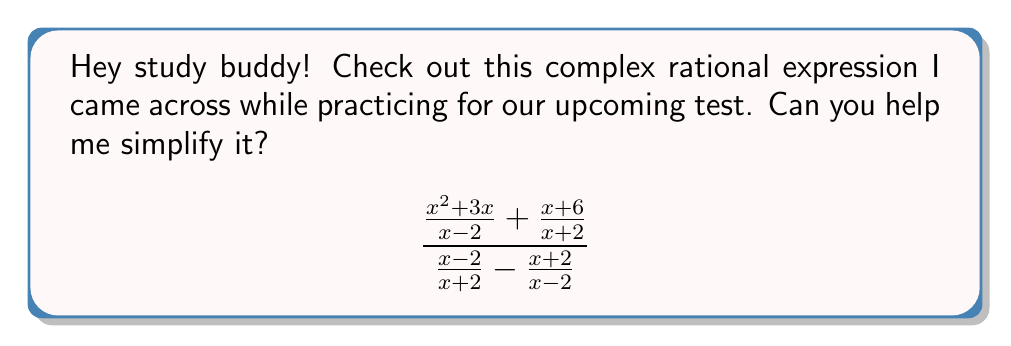Give your solution to this math problem. Sure! Let's break this down step-by-step:

1) First, let's find a common denominator for the numerator and denominator separately.

   For the numerator: LCD = $(x-2)(x+2)$
   For the denominator: LCD = $(x-2)(x+2)$

2) Let's start with the numerator:

   $$\frac{x^2 + 3x}{x - 2} \cdot \frac{x+2}{x+2} + \frac{x + 6}{x + 2} \cdot \frac{x-2}{x-2}$$
   
   $$= \frac{(x^2 + 3x)(x+2) + (x + 6)(x-2)}{(x-2)(x+2)}$$

3) Expand the numerator:

   $$= \frac{x^3 + 2x^2 + 3x^2 + 6x + x^2 - 2x + 6x - 12}{(x-2)(x+2)}$$
   
   $$= \frac{x^3 + 6x^2 + 10x - 12}{(x-2)(x+2)}$$

4) Now for the denominator:

   $$\frac{x - 2}{x + 2} \cdot \frac{x-2}{x-2} - \frac{x + 2}{x - 2} \cdot \frac{x+2}{x+2}$$
   
   $$= \frac{(x-2)^2 - (x+2)^2}{(x-2)(x+2)}$$

5) Expand the denominator:

   $$= \frac{x^2 - 4x + 4 - (x^2 + 4x + 4)}{(x-2)(x+2)}$$
   
   $$= \frac{-8x}{(x-2)(x+2)}$$

6) Now our expression looks like this:

   $$\frac{\frac{x^3 + 6x^2 + 10x - 12}{(x-2)(x+2)}}{\frac{-8x}{(x-2)(x+2)}}$$

7) Divide the numerator by the denominator:

   $$= \frac{x^3 + 6x^2 + 10x - 12}{-8x}$$

8) Simplify:

   $$= -\frac{x^2 + 6x + 10 - \frac{12}{x}}{8}$$

This is our simplified complex rational expression.
Answer: $-\frac{x^2 + 6x + 10 - \frac{12}{x}}{8}$ 